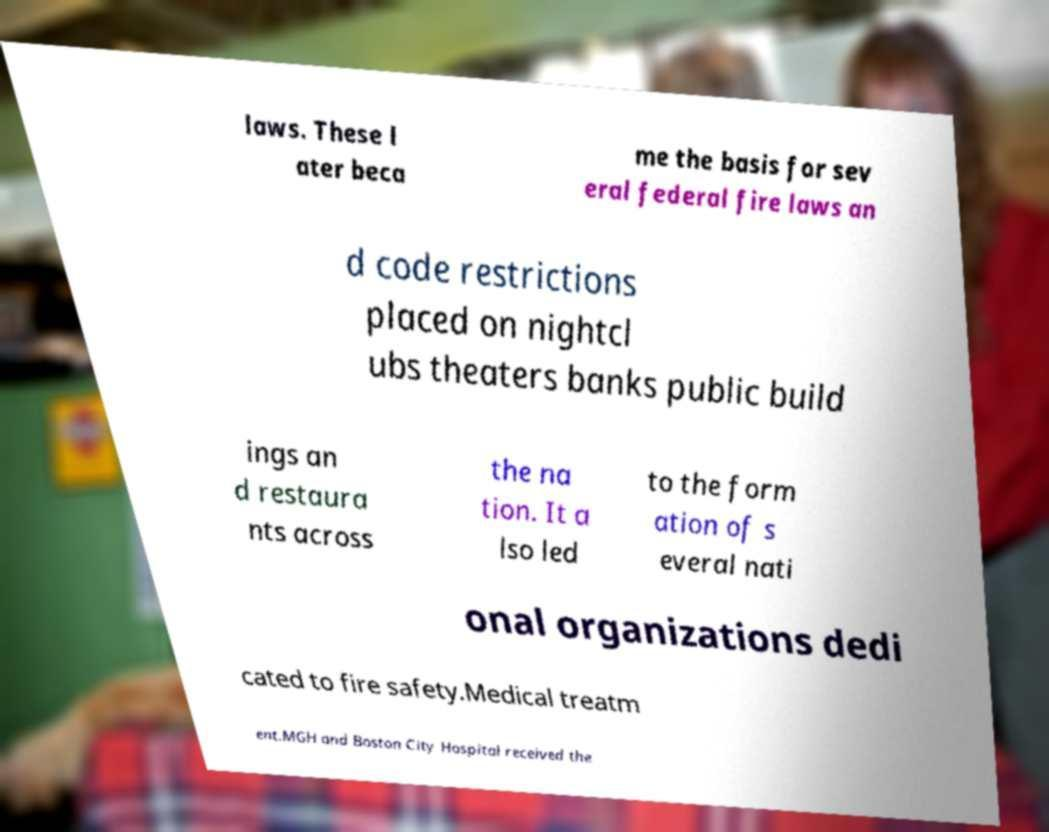Can you read and provide the text displayed in the image?This photo seems to have some interesting text. Can you extract and type it out for me? laws. These l ater beca me the basis for sev eral federal fire laws an d code restrictions placed on nightcl ubs theaters banks public build ings an d restaura nts across the na tion. It a lso led to the form ation of s everal nati onal organizations dedi cated to fire safety.Medical treatm ent.MGH and Boston City Hospital received the 